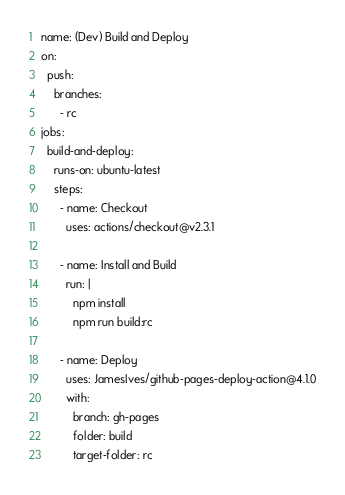<code> <loc_0><loc_0><loc_500><loc_500><_YAML_>name: (Dev) Build and Deploy
on: 
  push:
    branches:
      - rc
jobs:
  build-and-deploy:
    runs-on: ubuntu-latest
    steps:
      - name: Checkout
        uses: actions/checkout@v2.3.1

      - name: Install and Build
        run: |
          npm install
          npm run build:rc

      - name: Deploy
        uses: JamesIves/github-pages-deploy-action@4.1.0
        with:
          branch: gh-pages
          folder: build
          target-folder: rc
</code> 